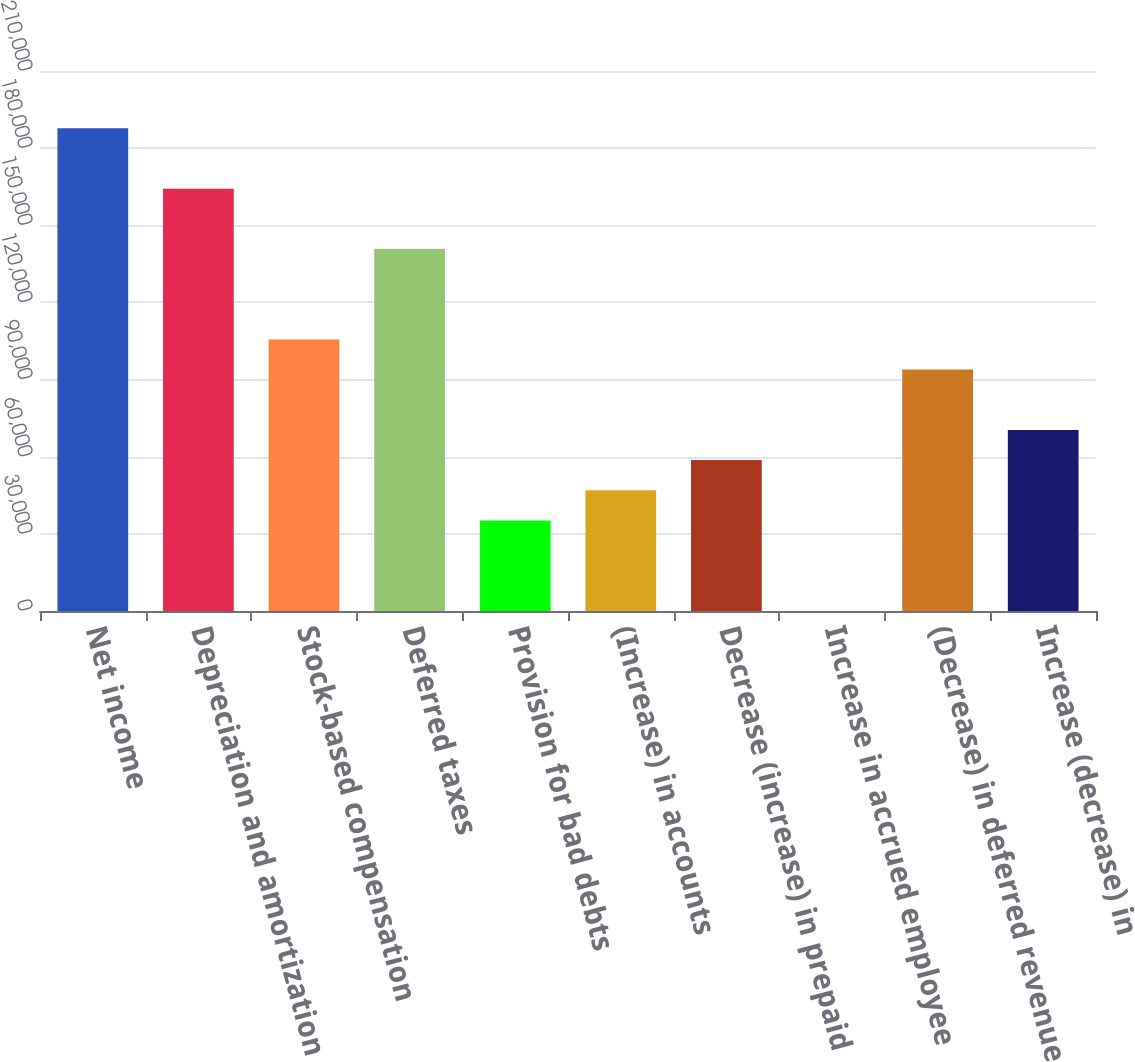Convert chart. <chart><loc_0><loc_0><loc_500><loc_500><bar_chart><fcel>Net income<fcel>Depreciation and amortization<fcel>Stock-based compensation<fcel>Deferred taxes<fcel>Provision for bad debts<fcel>(Increase) in accounts<fcel>Decrease (increase) in prepaid<fcel>Increase in accrued employee<fcel>(Decrease) in deferred revenue<fcel>Increase (decrease) in<nl><fcel>187691<fcel>164236<fcel>105596<fcel>140780<fcel>35228.7<fcel>46956.6<fcel>58684.5<fcel>45<fcel>93868.2<fcel>70412.4<nl></chart> 